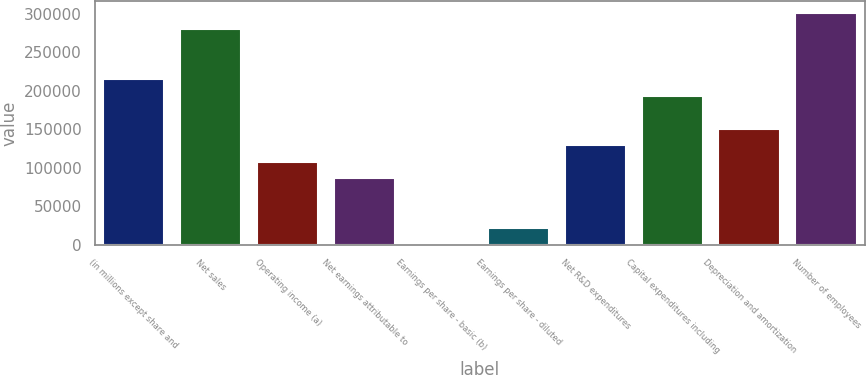<chart> <loc_0><loc_0><loc_500><loc_500><bar_chart><fcel>(in millions except share and<fcel>Net sales<fcel>Operating income (a)<fcel>Net earnings attributable to<fcel>Earnings per share - basic (b)<fcel>Earnings per share - diluted<fcel>Net R&D expenditures<fcel>Capital expenditures including<fcel>Depreciation and amortization<fcel>Number of employees<nl><fcel>215328<fcel>279926<fcel>107664<fcel>86131.5<fcel>0.55<fcel>21533.3<fcel>129197<fcel>193795<fcel>150730<fcel>301459<nl></chart> 